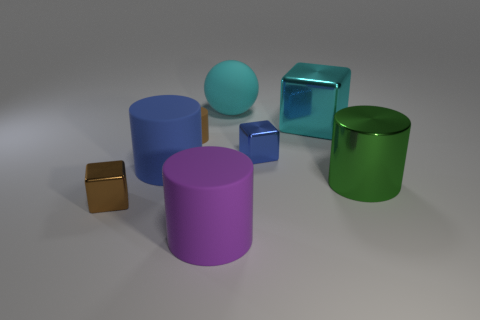What colors do the objects in the image have, and how many are there of each? In the image, we observe a variety of colors. There's one green cylindrical container, one cyan object with a rounded top, one dark blue cube, one purple cylinder, one blue cylinder, and two smaller objects, one of which is gold and the other silver. 